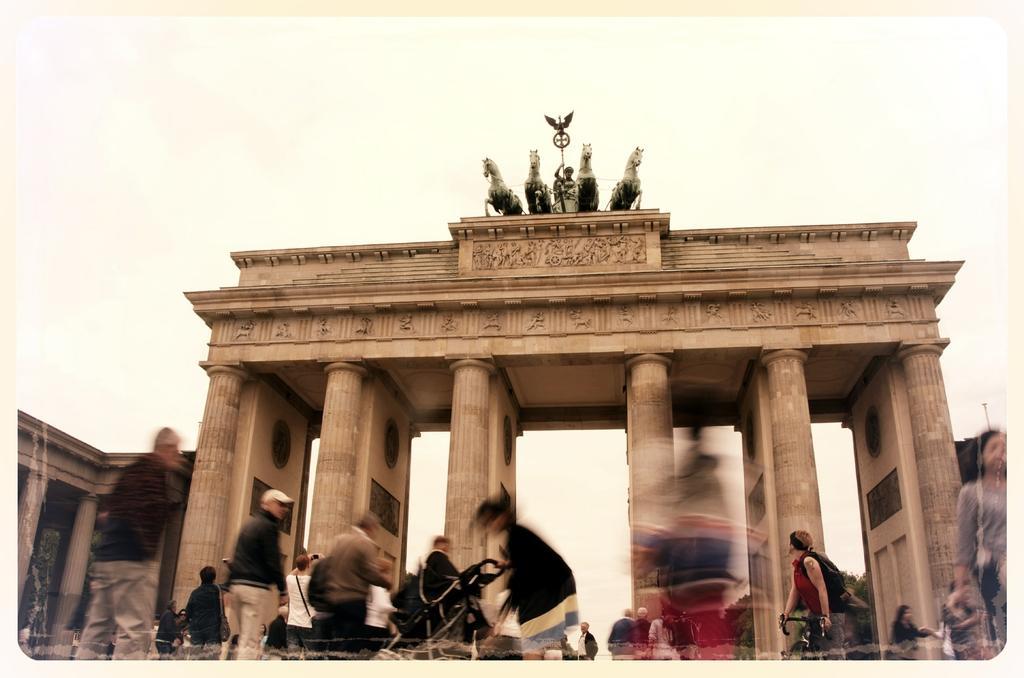Could you give a brief overview of what you see in this image? There is a Brandenburg Gate in the center of the image and there is sculpture at the top side of the image and there are people and bicycles at the bottom side of the image, there are trees in the background area and there are pillars on the left side. 